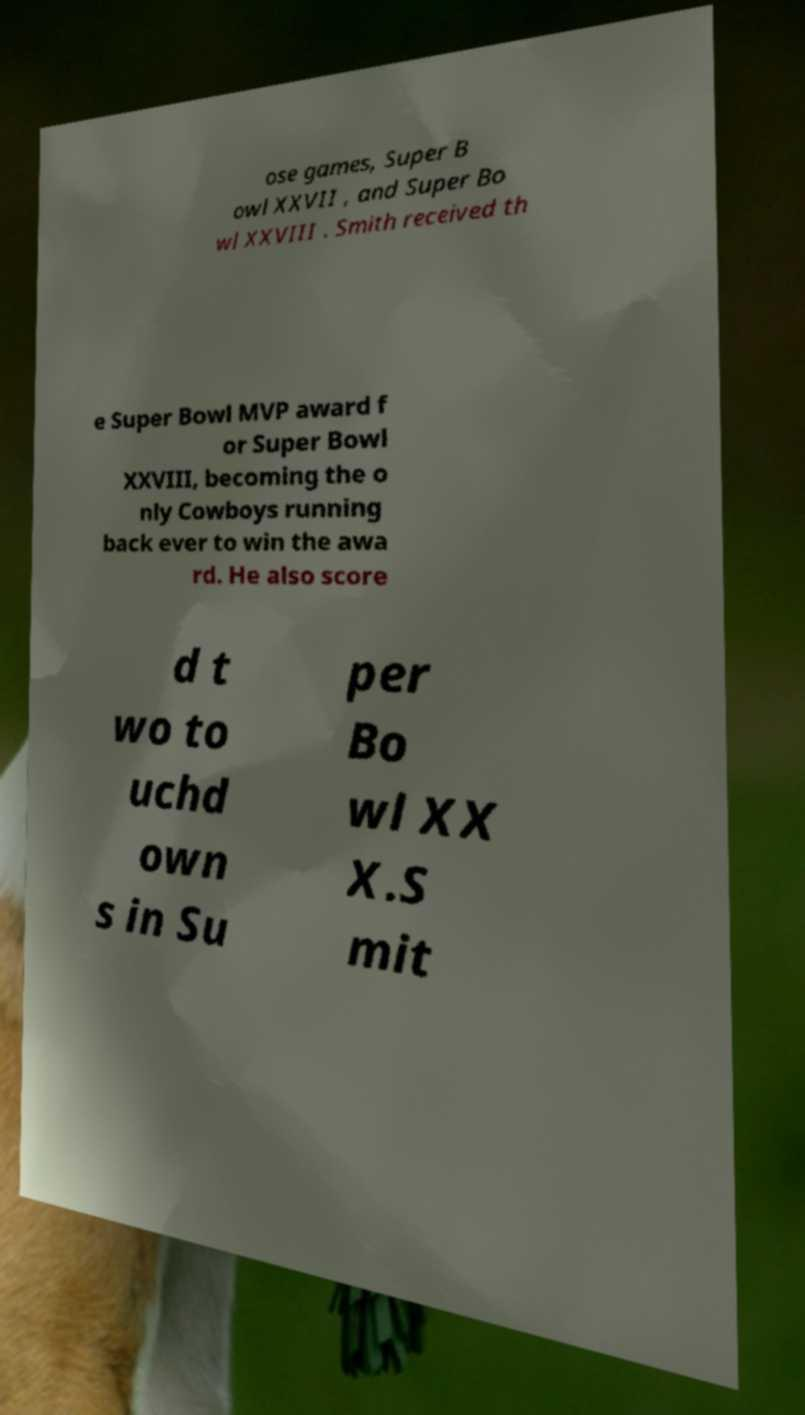I need the written content from this picture converted into text. Can you do that? ose games, Super B owl XXVII , and Super Bo wl XXVIII . Smith received th e Super Bowl MVP award f or Super Bowl XXVIII, becoming the o nly Cowboys running back ever to win the awa rd. He also score d t wo to uchd own s in Su per Bo wl XX X.S mit 